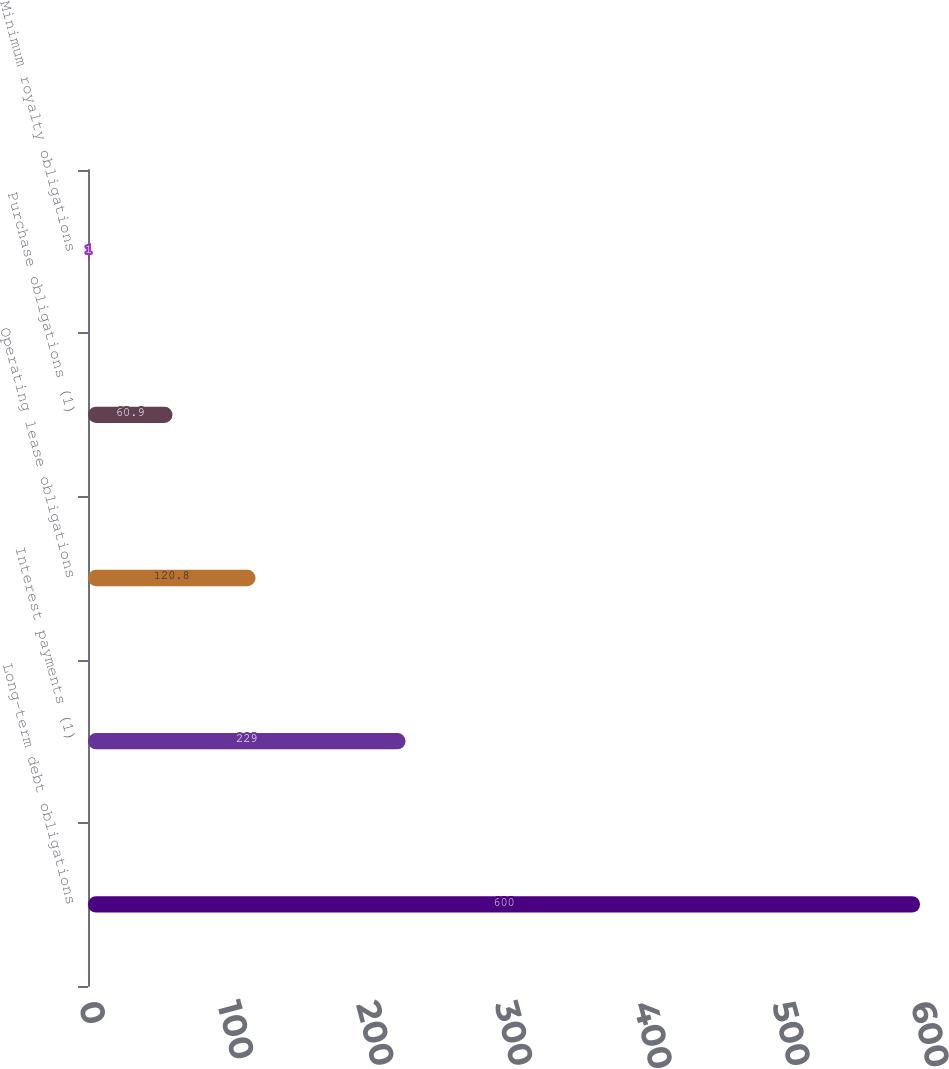Convert chart. <chart><loc_0><loc_0><loc_500><loc_500><bar_chart><fcel>Long-term debt obligations<fcel>Interest payments (1)<fcel>Operating lease obligations<fcel>Purchase obligations (1)<fcel>Minimum royalty obligations<nl><fcel>600<fcel>229<fcel>120.8<fcel>60.9<fcel>1<nl></chart> 